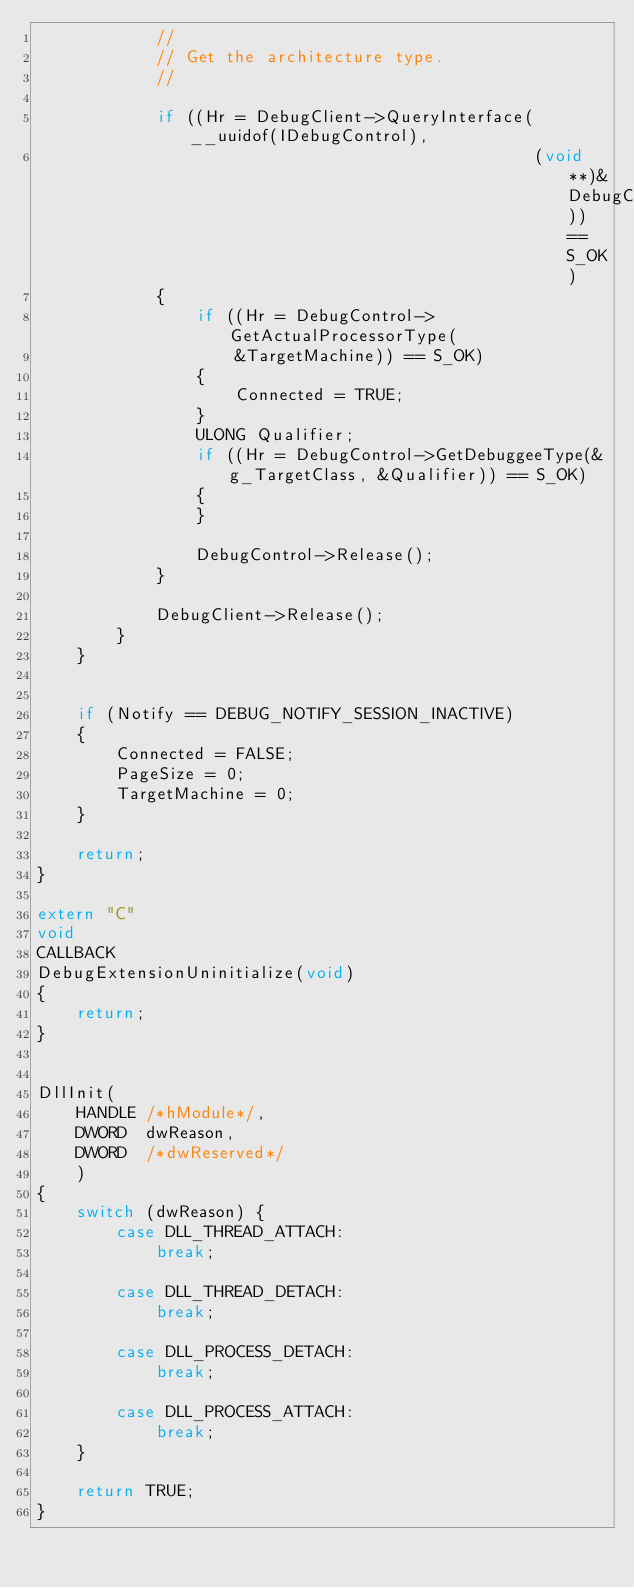Convert code to text. <code><loc_0><loc_0><loc_500><loc_500><_C++_>            //
            // Get the architecture type.
            //

            if ((Hr = DebugClient->QueryInterface(__uuidof(IDebugControl),
                                                  (void **)&DebugControl)) == S_OK)
            {
                if ((Hr = DebugControl->GetActualProcessorType(
                    &TargetMachine)) == S_OK)
                {
                    Connected = TRUE;
                }
                ULONG Qualifier;
                if ((Hr = DebugControl->GetDebuggeeType(&g_TargetClass, &Qualifier)) == S_OK)
                {
                }

                DebugControl->Release();
            }

            DebugClient->Release();
        }
    }


    if (Notify == DEBUG_NOTIFY_SESSION_INACTIVE)
    {
        Connected = FALSE;
        PageSize = 0;
        TargetMachine = 0;
    }

    return;
}

extern "C"
void
CALLBACK
DebugExtensionUninitialize(void)
{
    return;
}


DllInit(
    HANDLE /*hModule*/,
    DWORD  dwReason,
    DWORD  /*dwReserved*/
    )
{
    switch (dwReason) {
        case DLL_THREAD_ATTACH:
            break;

        case DLL_THREAD_DETACH:
            break;

        case DLL_PROCESS_DETACH:
            break;

        case DLL_PROCESS_ATTACH:
            break;
    }

    return TRUE;
}

</code> 